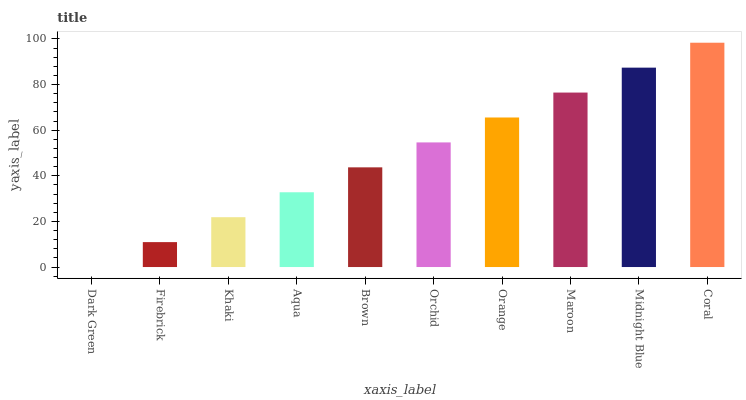Is Dark Green the minimum?
Answer yes or no. Yes. Is Coral the maximum?
Answer yes or no. Yes. Is Firebrick the minimum?
Answer yes or no. No. Is Firebrick the maximum?
Answer yes or no. No. Is Firebrick greater than Dark Green?
Answer yes or no. Yes. Is Dark Green less than Firebrick?
Answer yes or no. Yes. Is Dark Green greater than Firebrick?
Answer yes or no. No. Is Firebrick less than Dark Green?
Answer yes or no. No. Is Orchid the high median?
Answer yes or no. Yes. Is Brown the low median?
Answer yes or no. Yes. Is Firebrick the high median?
Answer yes or no. No. Is Dark Green the low median?
Answer yes or no. No. 